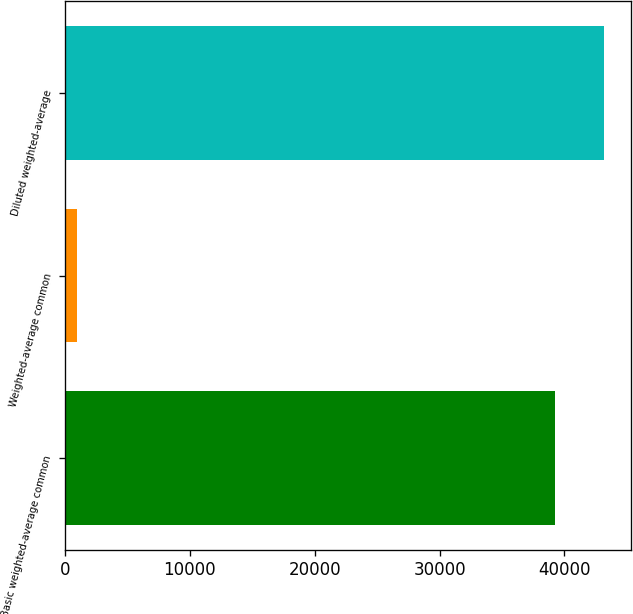<chart> <loc_0><loc_0><loc_500><loc_500><bar_chart><fcel>Basic weighted-average common<fcel>Weighted-average common<fcel>Diluted weighted-average<nl><fcel>39258<fcel>1003<fcel>43183.8<nl></chart> 